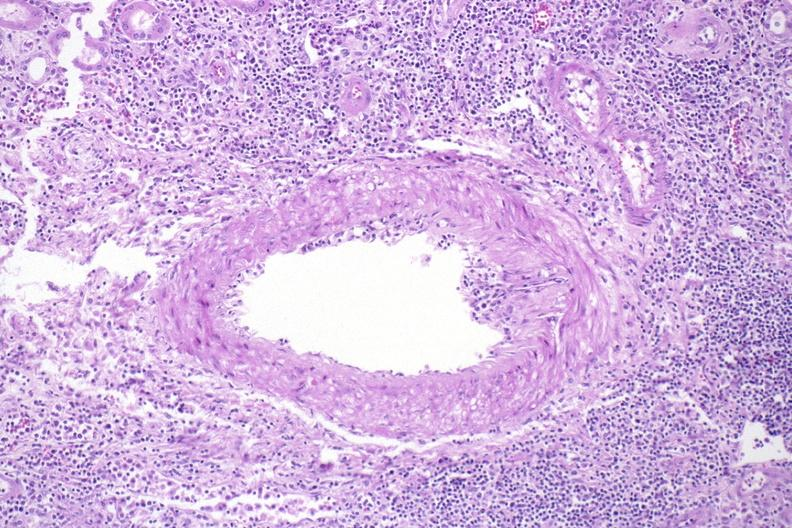does this image show kidney, acute transplant rejection?
Answer the question using a single word or phrase. Yes 